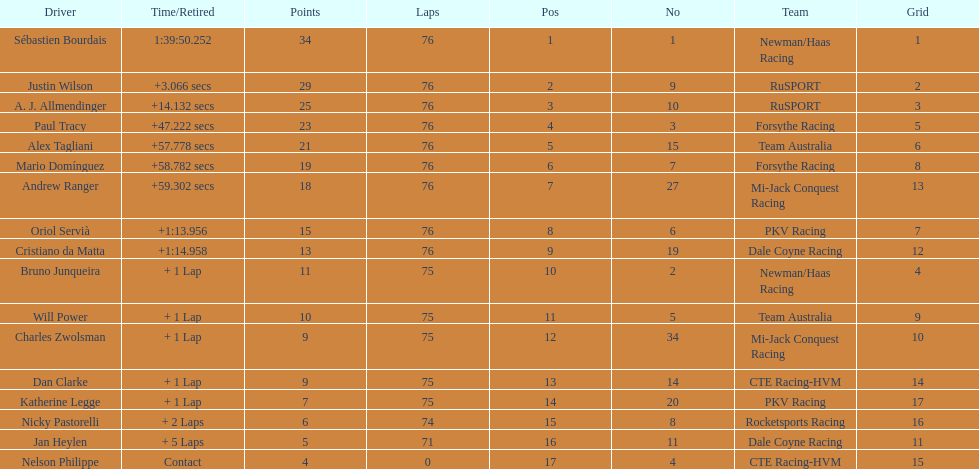Which driver has the least amount of points? Nelson Philippe. 